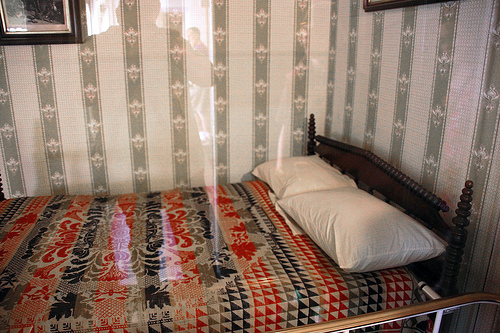Are there both pillows and pictures in the photo?
Answer the question using a single word or phrase. Yes What color is the pillow on the right side? White 